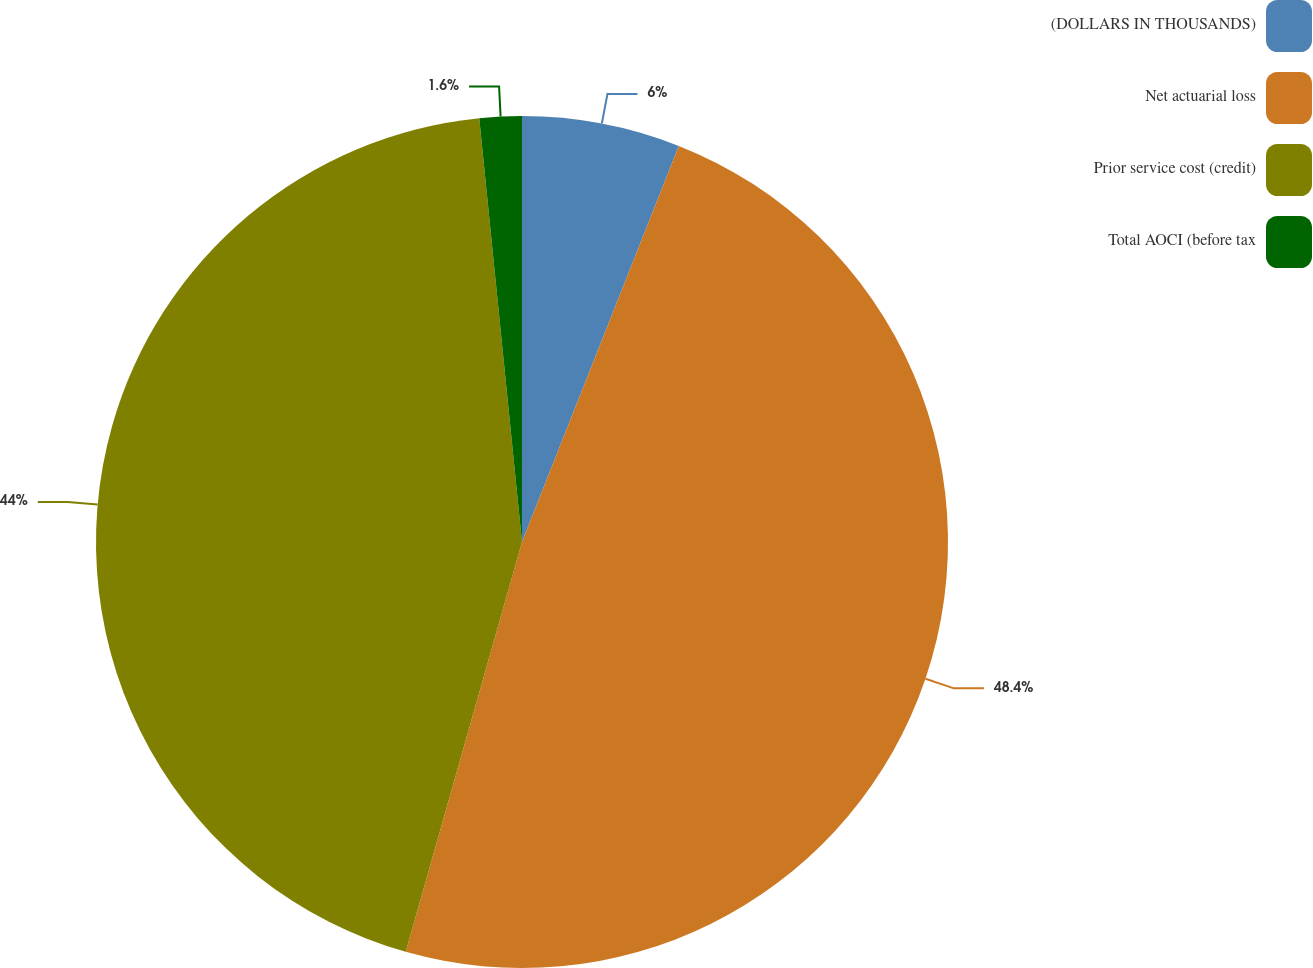Convert chart. <chart><loc_0><loc_0><loc_500><loc_500><pie_chart><fcel>(DOLLARS IN THOUSANDS)<fcel>Net actuarial loss<fcel>Prior service cost (credit)<fcel>Total AOCI (before tax<nl><fcel>6.0%<fcel>48.4%<fcel>44.0%<fcel>1.6%<nl></chart> 